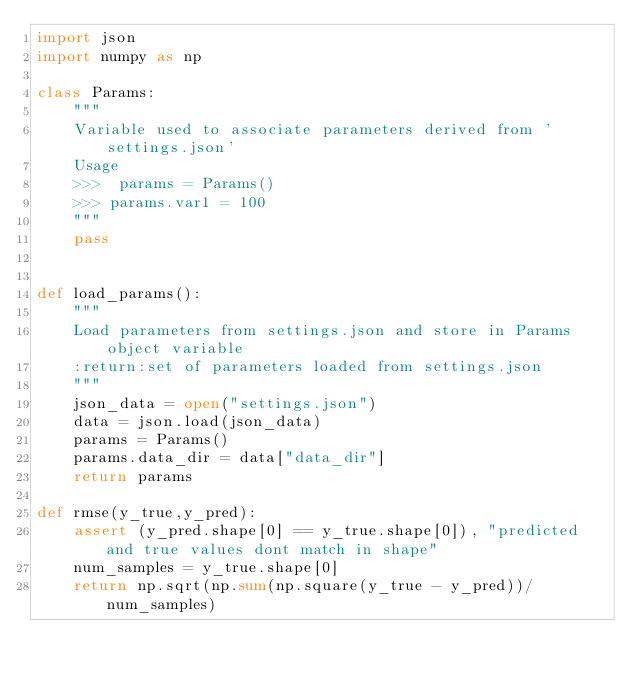<code> <loc_0><loc_0><loc_500><loc_500><_Python_>import json
import numpy as np

class Params:
    """
    Variable used to associate parameters derived from 'settings.json'
    Usage
    >>>  params = Params()
    >>> params.var1 = 100
    """
    pass


def load_params():
    """
    Load parameters from settings.json and store in Params object variable
    :return:set of parameters loaded from settings.json
    """
    json_data = open("settings.json")
    data = json.load(json_data)
    params = Params()
    params.data_dir = data["data_dir"]
    return params

def rmse(y_true,y_pred):
    assert (y_pred.shape[0] == y_true.shape[0]), "predicted and true values dont match in shape"
    num_samples = y_true.shape[0]
    return np.sqrt(np.sum(np.square(y_true - y_pred))/num_samples)</code> 